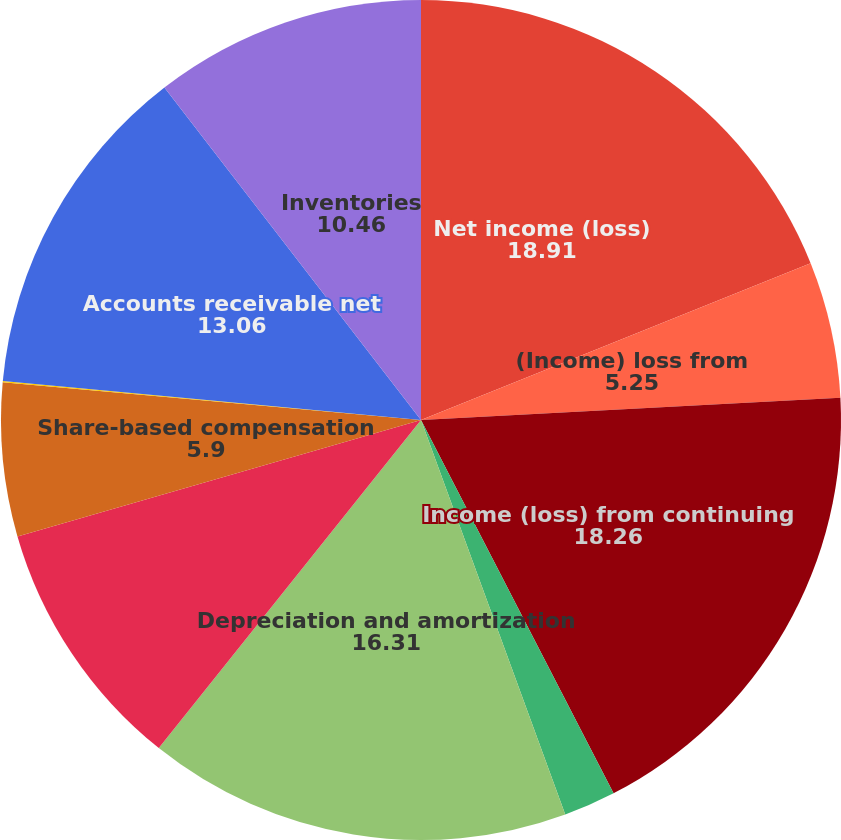Convert chart to OTSL. <chart><loc_0><loc_0><loc_500><loc_500><pie_chart><fcel>Net income (loss)<fcel>(Income) loss from<fcel>Income (loss) from continuing<fcel>Non-cash restructuring and<fcel>Depreciation and amortization<fcel>Tax sharing (income) expense<fcel>Share-based compensation<fcel>Other<fcel>Accounts receivable net<fcel>Inventories<nl><fcel>18.91%<fcel>5.25%<fcel>18.26%<fcel>2.0%<fcel>16.31%<fcel>9.8%<fcel>5.9%<fcel>0.05%<fcel>13.06%<fcel>10.46%<nl></chart> 